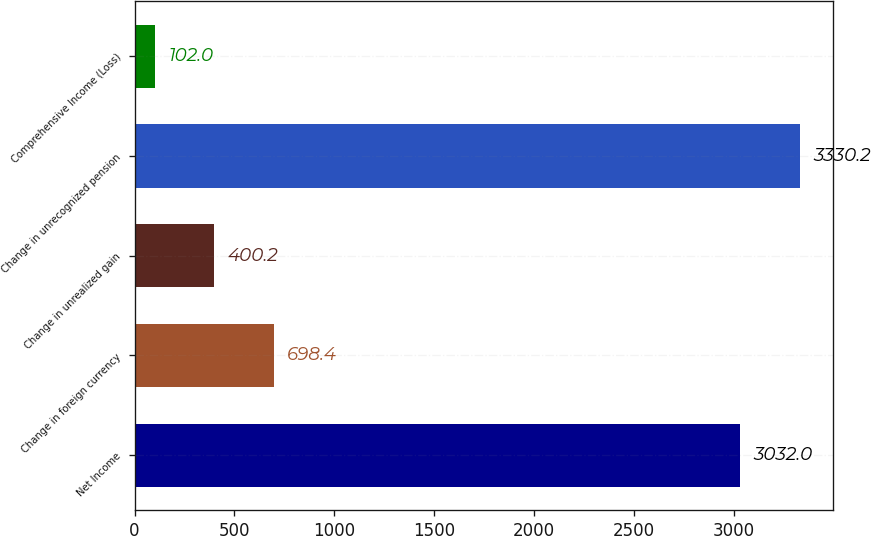Convert chart to OTSL. <chart><loc_0><loc_0><loc_500><loc_500><bar_chart><fcel>Net Income<fcel>Change in foreign currency<fcel>Change in unrealized gain<fcel>Change in unrecognized pension<fcel>Comprehensive Income (Loss)<nl><fcel>3032<fcel>698.4<fcel>400.2<fcel>3330.2<fcel>102<nl></chart> 